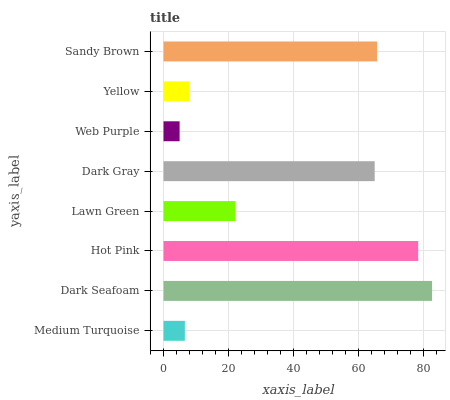Is Web Purple the minimum?
Answer yes or no. Yes. Is Dark Seafoam the maximum?
Answer yes or no. Yes. Is Hot Pink the minimum?
Answer yes or no. No. Is Hot Pink the maximum?
Answer yes or no. No. Is Dark Seafoam greater than Hot Pink?
Answer yes or no. Yes. Is Hot Pink less than Dark Seafoam?
Answer yes or no. Yes. Is Hot Pink greater than Dark Seafoam?
Answer yes or no. No. Is Dark Seafoam less than Hot Pink?
Answer yes or no. No. Is Dark Gray the high median?
Answer yes or no. Yes. Is Lawn Green the low median?
Answer yes or no. Yes. Is Yellow the high median?
Answer yes or no. No. Is Yellow the low median?
Answer yes or no. No. 